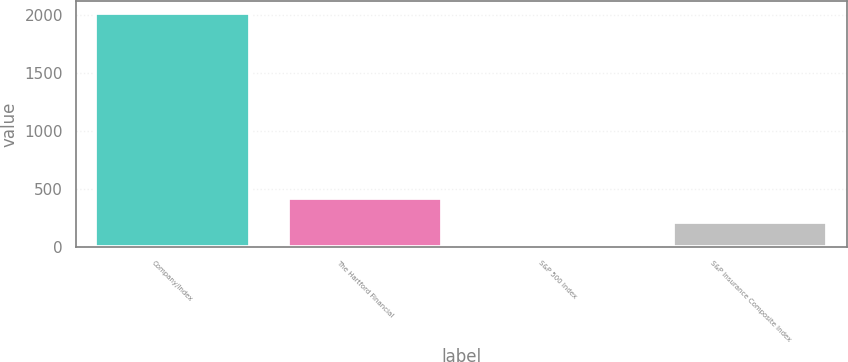Convert chart to OTSL. <chart><loc_0><loc_0><loc_500><loc_500><bar_chart><fcel>Company/Index<fcel>The Hartford Financial<fcel>S&P 500 Index<fcel>S&P Insurance Composite Index<nl><fcel>2012<fcel>415.2<fcel>16<fcel>215.6<nl></chart> 